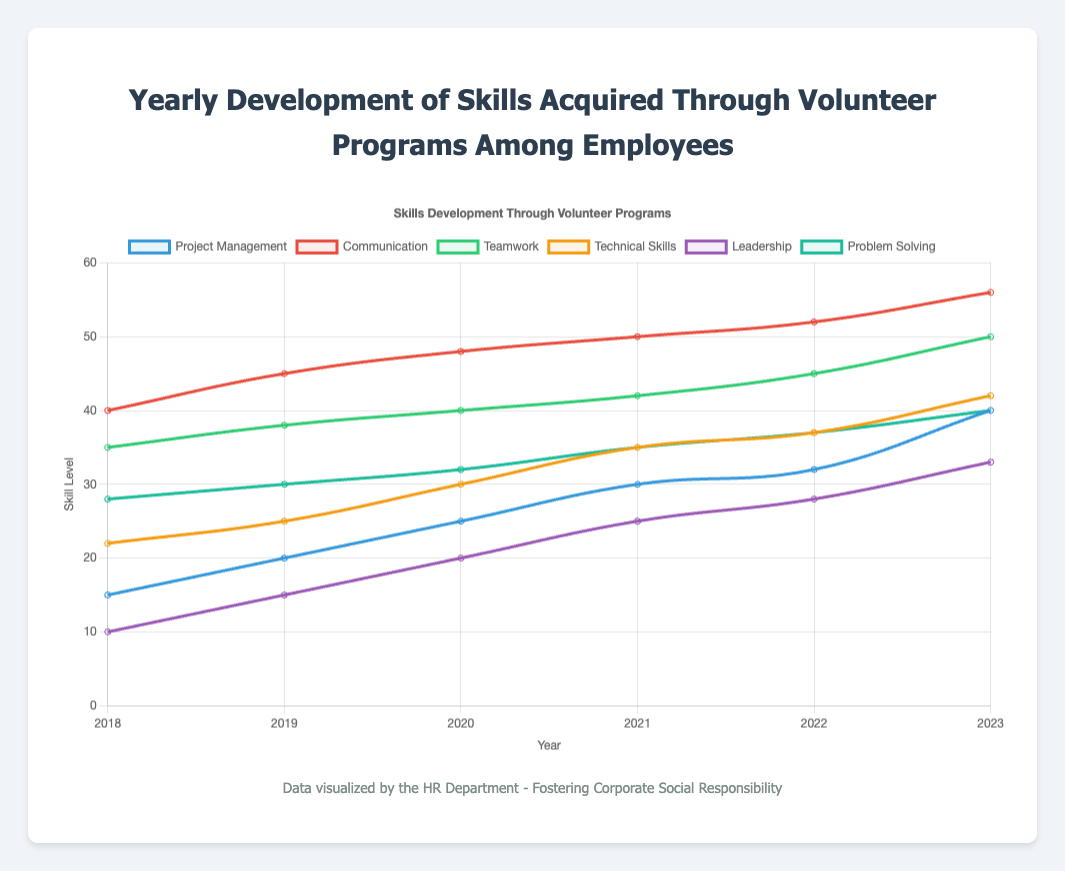What's the trend in Project Management skills from 2018 to 2023? The chart shows a line representing the trend of Project Management skills over the years. The values increase from 15 in 2018 to 40 in 2023, indicating an upward trend.
Answer: Upward Which skill showed the highest value in 2023? By examining the chart, Communication shows a value of 56 in 2023, which is the highest among all the skills.
Answer: Communication How many skills showed an increase in their values from 2018 to 2023? By analyzing the lines for each skill, we can see that all six skills (Project Management, Communication, Teamwork, Technical Skills, Leadership, and Problem Solving) increased their values over the years.
Answer: Six Comparing 2020 and 2021, which skill had the largest increase? By subtracting the 2020 values from the 2021 values for each skill, we find that Technical Skills had the largest increase from 30 to 35, which is an increase of 5.
Answer: Technical Skills Among the skills, which one grew the slowest from 2018 to 2023? By comparing the total increase for each skill from 2018 to 2023, Leadership grew from 10 to 33, an increase of 23. This is slower relative to others like Communication (16) and Project Management (25).
Answer: Leadership What is the average skill level for Communication from 2018 to 2023? The values for Communication are 40, 45, 48, 50, 52, and 56. Summing these gives 291. Dividing by 6 (number of years) results in an average of 48.5.
Answer: 48.5 Which year shows the most significant increase in Leadership skills compared to the previous year? By comparing year-to-year changes for Leadership, from 10 to 15 (5), 15 to 20 (5), 20 to 25 (5), 25 to 28 (3), and 28 to 33 (5), we see the largest increment (5) occurred three times, so the year 2019, 2020, and 2023 all show marked increases.
Answer: 2019, 2020, 2023 In 2023, how many more employees acquired Communication skills than Leadership skills? The figure shows 56 employees acquiring Communication skills and 33 acquiring Leadership skills in 2023. The difference is 56 - 33 = 23 more employees.
Answer: 23 What skill had the highest growth rate between 2018 and 2023 and how is it calculated? Growth rate can be calculated as (Final Value - Initial Value) / Initial Value. For Project Management: (40-15)/15 = 1.67; Communication: (56-40)/40 = 0.4; Teamwork: (50-35)/35 = 0.43; Technical Skills: (42-22)/22 = 0.91; Leadership: (33-10)/10 = 2.3; Problem Solving: (40-28)/28 = 0.43. The highest growth rate is for Leadership with a rate of 2.3.
Answer: Leadership What is the total skill value acquired for Technical Skills over all the years combined? Summing the values for Technical Skills from each year: 22 + 25 + 30 + 35 + 37 + 42 = 191.
Answer: 191 